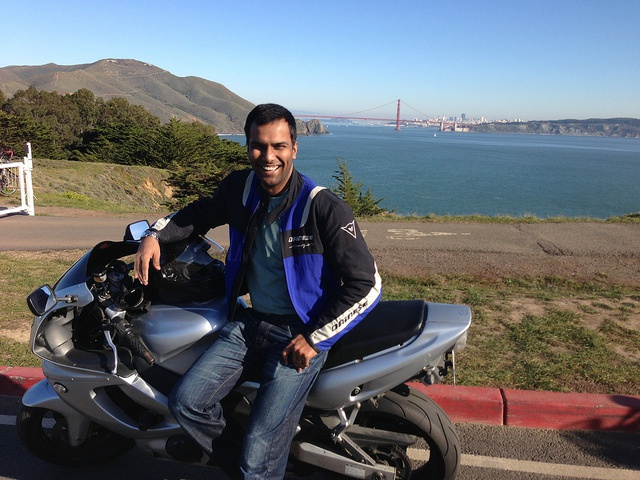Describe the objects in this image and their specific colors. I can see motorcycle in lightblue, black, gray, and darkgray tones and people in lightblue, black, gray, navy, and darkblue tones in this image. 